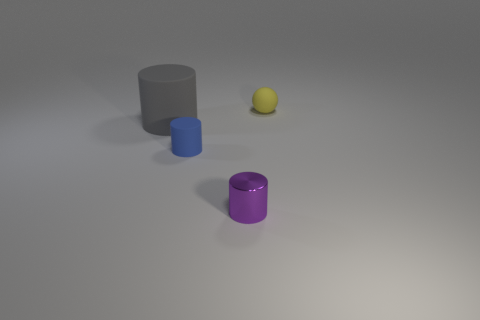Subtract all small purple shiny cylinders. How many cylinders are left? 2 Subtract all purple cylinders. How many cylinders are left? 2 Subtract 1 cylinders. How many cylinders are left? 2 Subtract all cylinders. How many objects are left? 1 Add 2 small blue rubber cubes. How many objects exist? 6 Subtract 0 red spheres. How many objects are left? 4 Subtract all gray cylinders. Subtract all brown balls. How many cylinders are left? 2 Subtract all big yellow blocks. Subtract all blue rubber objects. How many objects are left? 3 Add 3 purple metal cylinders. How many purple metal cylinders are left? 4 Add 4 tiny yellow objects. How many tiny yellow objects exist? 5 